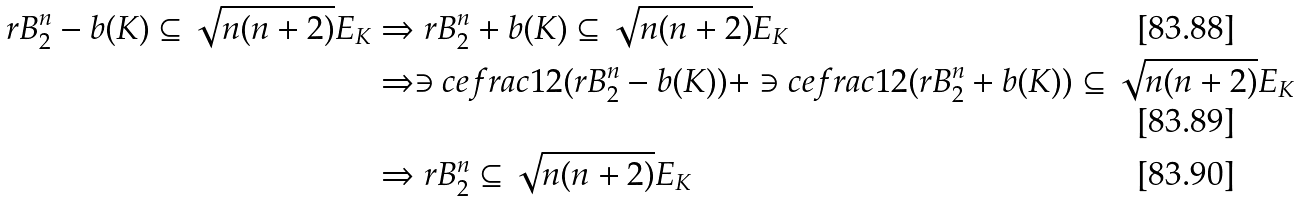<formula> <loc_0><loc_0><loc_500><loc_500>r B _ { 2 } ^ { n } - b ( K ) \subseteq \sqrt { n ( n + 2 ) } E _ { K } & \Rightarrow r B _ { 2 } ^ { n } + b ( K ) \subseteq \sqrt { n ( n + 2 ) } E _ { K } \\ & \Rightarrow \ni c e f r a c { 1 } { 2 } ( r B _ { 2 } ^ { n } - b ( K ) ) + \ni c e f r a c { 1 } { 2 } ( r B _ { 2 } ^ { n } + b ( K ) ) \subseteq \sqrt { n ( n + 2 ) } E _ { K } \\ & \Rightarrow r B _ { 2 } ^ { n } \subseteq \sqrt { n ( n + 2 ) } E _ { K }</formula> 